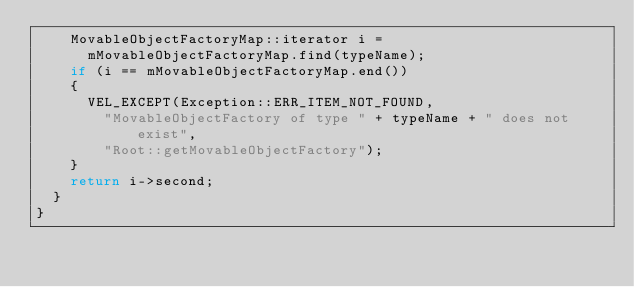Convert code to text. <code><loc_0><loc_0><loc_500><loc_500><_C++_>		MovableObjectFactoryMap::iterator i =
			mMovableObjectFactoryMap.find(typeName);
		if (i == mMovableObjectFactoryMap.end())
		{
			VEL_EXCEPT(Exception::ERR_ITEM_NOT_FOUND,
				"MovableObjectFactory of type " + typeName + " does not exist",
				"Root::getMovableObjectFactory");
		}
		return i->second;
	}
}</code> 